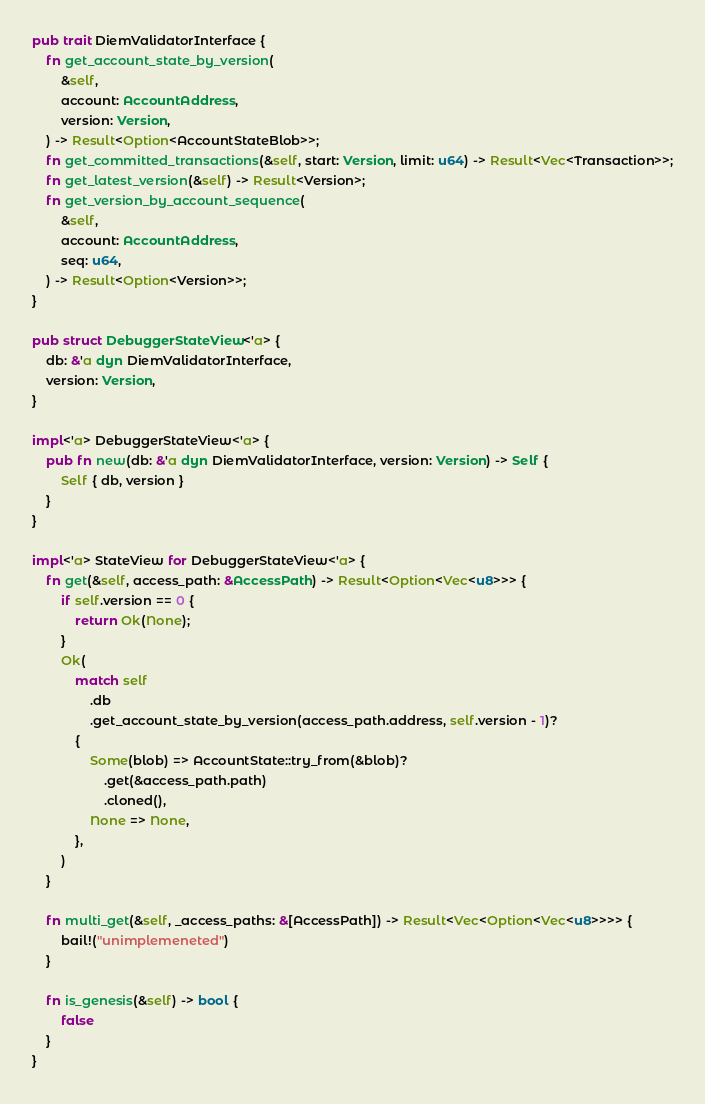Convert code to text. <code><loc_0><loc_0><loc_500><loc_500><_Rust_>
pub trait DiemValidatorInterface {
    fn get_account_state_by_version(
        &self,
        account: AccountAddress,
        version: Version,
    ) -> Result<Option<AccountStateBlob>>;
    fn get_committed_transactions(&self, start: Version, limit: u64) -> Result<Vec<Transaction>>;
    fn get_latest_version(&self) -> Result<Version>;
    fn get_version_by_account_sequence(
        &self,
        account: AccountAddress,
        seq: u64,
    ) -> Result<Option<Version>>;
}

pub struct DebuggerStateView<'a> {
    db: &'a dyn DiemValidatorInterface,
    version: Version,
}

impl<'a> DebuggerStateView<'a> {
    pub fn new(db: &'a dyn DiemValidatorInterface, version: Version) -> Self {
        Self { db, version }
    }
}

impl<'a> StateView for DebuggerStateView<'a> {
    fn get(&self, access_path: &AccessPath) -> Result<Option<Vec<u8>>> {
        if self.version == 0 {
            return Ok(None);
        }
        Ok(
            match self
                .db
                .get_account_state_by_version(access_path.address, self.version - 1)?
            {
                Some(blob) => AccountState::try_from(&blob)?
                    .get(&access_path.path)
                    .cloned(),
                None => None,
            },
        )
    }

    fn multi_get(&self, _access_paths: &[AccessPath]) -> Result<Vec<Option<Vec<u8>>>> {
        bail!("unimplemeneted")
    }

    fn is_genesis(&self) -> bool {
        false
    }
}
</code> 